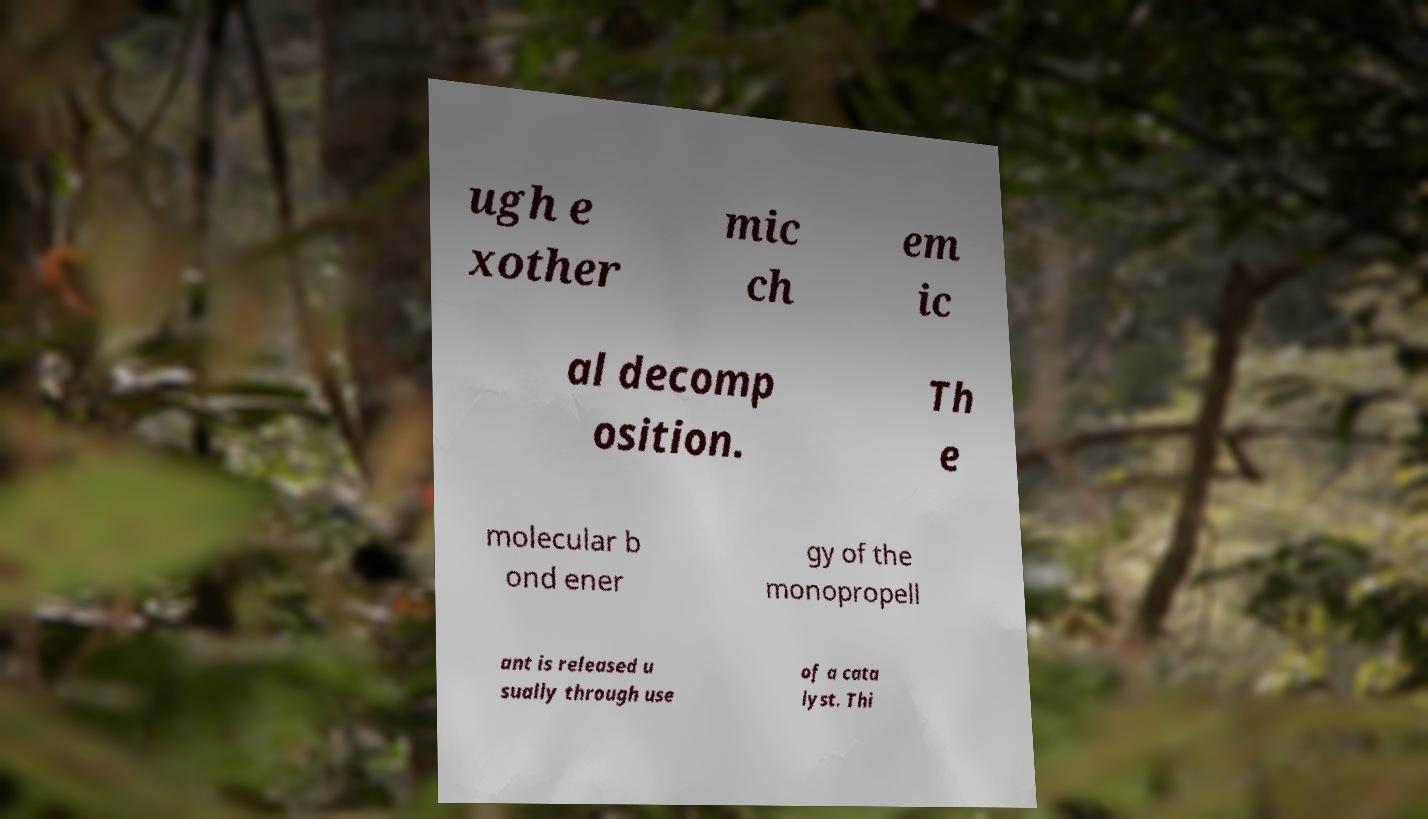There's text embedded in this image that I need extracted. Can you transcribe it verbatim? ugh e xother mic ch em ic al decomp osition. Th e molecular b ond ener gy of the monopropell ant is released u sually through use of a cata lyst. Thi 